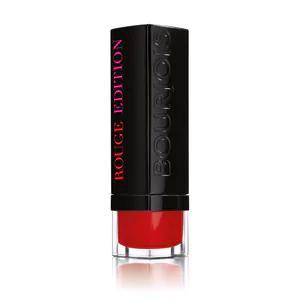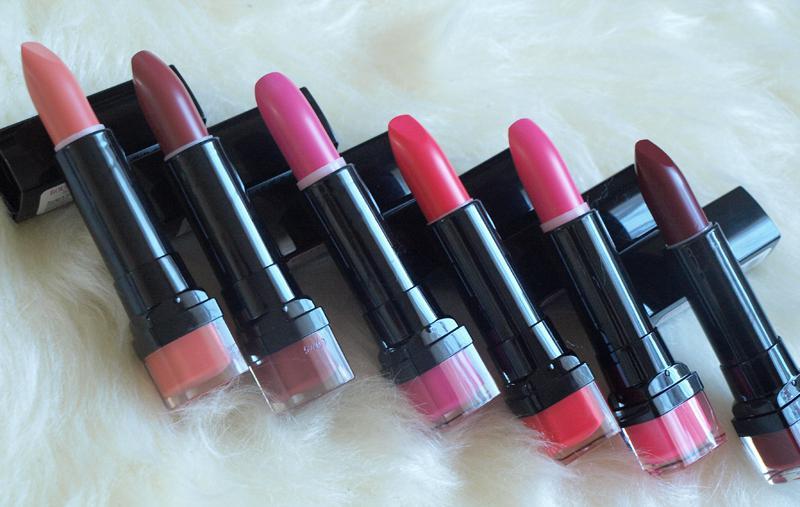The first image is the image on the left, the second image is the image on the right. Considering the images on both sides, is "Two lipsticks with the color extended stand beside the black cap of each tube." valid? Answer yes or no. No. The first image is the image on the left, the second image is the image on the right. Considering the images on both sides, is "Images show a total of two red lipsticks with black caps." valid? Answer yes or no. No. 